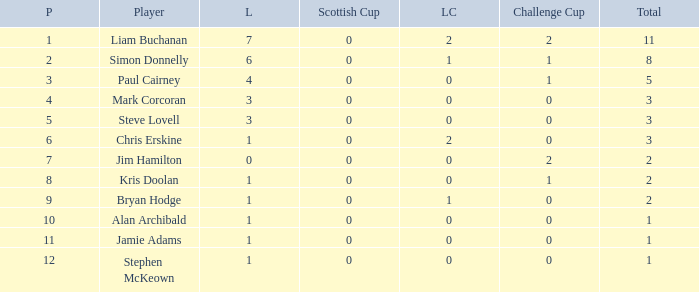What is Kris doolan's league number? 1.0. I'm looking to parse the entire table for insights. Could you assist me with that? {'header': ['P', 'Player', 'L', 'Scottish Cup', 'LC', 'Challenge Cup', 'Total'], 'rows': [['1', 'Liam Buchanan', '7', '0', '2', '2', '11'], ['2', 'Simon Donnelly', '6', '0', '1', '1', '8'], ['3', 'Paul Cairney', '4', '0', '0', '1', '5'], ['4', 'Mark Corcoran', '3', '0', '0', '0', '3'], ['5', 'Steve Lovell', '3', '0', '0', '0', '3'], ['6', 'Chris Erskine', '1', '0', '2', '0', '3'], ['7', 'Jim Hamilton', '0', '0', '0', '2', '2'], ['8', 'Kris Doolan', '1', '0', '0', '1', '2'], ['9', 'Bryan Hodge', '1', '0', '1', '0', '2'], ['10', 'Alan Archibald', '1', '0', '0', '0', '1'], ['11', 'Jamie Adams', '1', '0', '0', '0', '1'], ['12', 'Stephen McKeown', '1', '0', '0', '0', '1']]} 